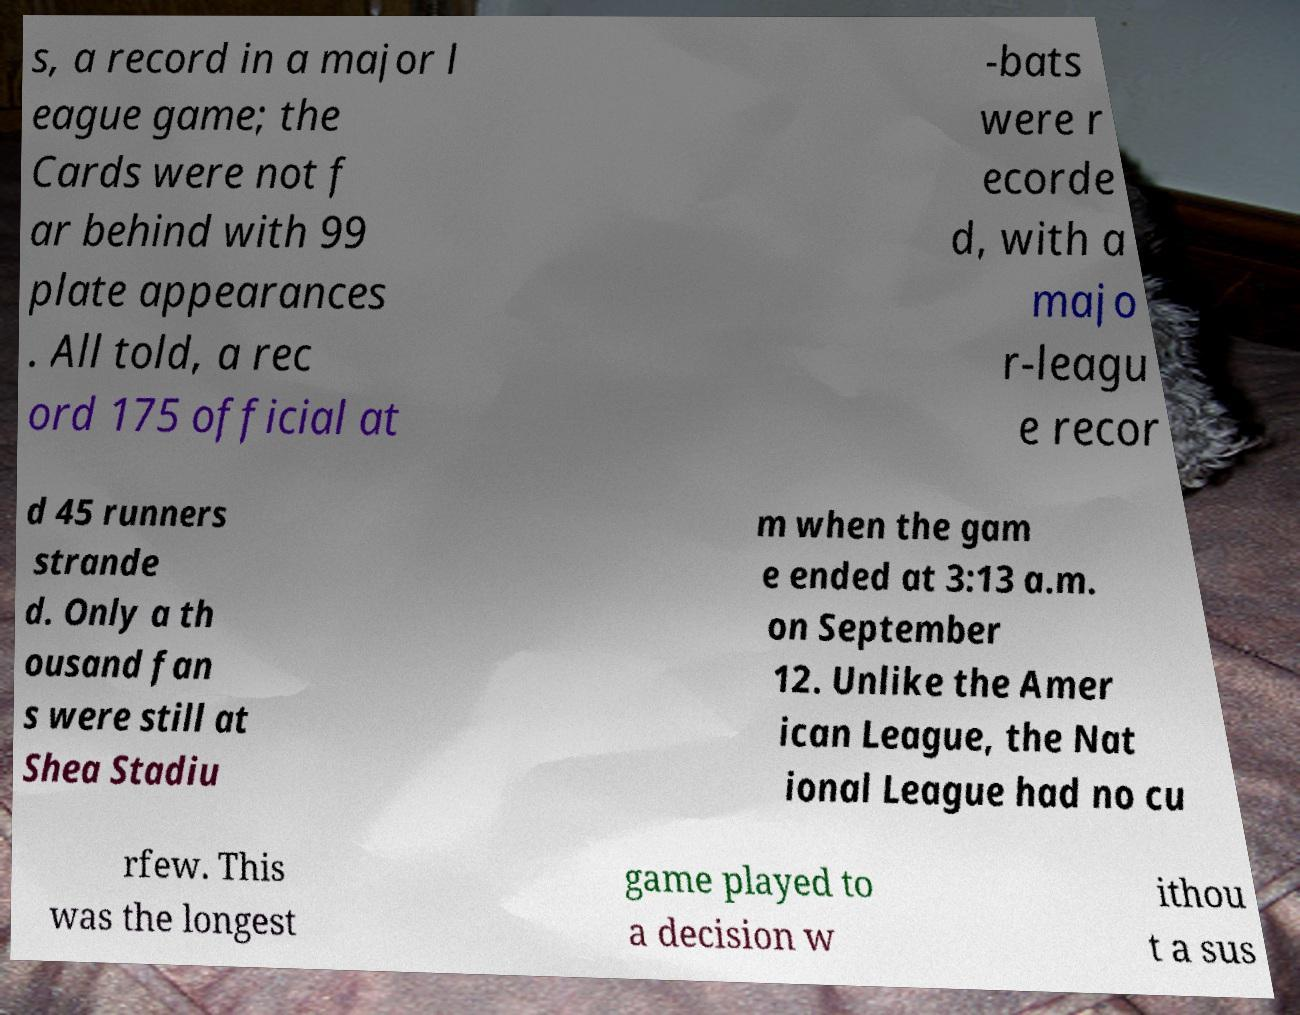Could you extract and type out the text from this image? s, a record in a major l eague game; the Cards were not f ar behind with 99 plate appearances . All told, a rec ord 175 official at -bats were r ecorde d, with a majo r-leagu e recor d 45 runners strande d. Only a th ousand fan s were still at Shea Stadiu m when the gam e ended at 3:13 a.m. on September 12. Unlike the Amer ican League, the Nat ional League had no cu rfew. This was the longest game played to a decision w ithou t a sus 